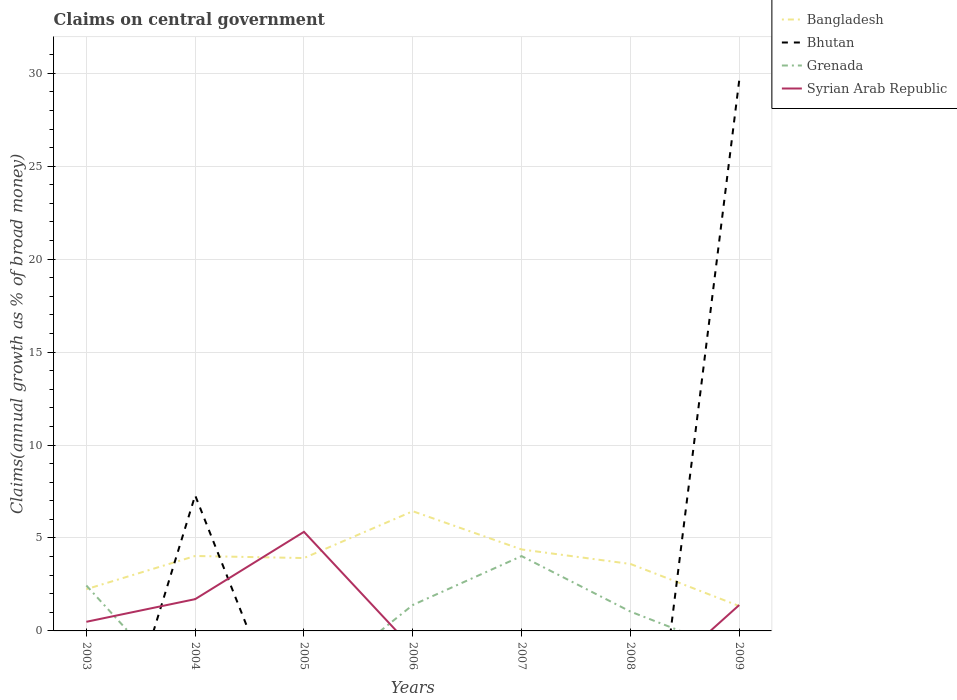Across all years, what is the maximum percentage of broad money claimed on centeral government in Grenada?
Your answer should be compact. 0. What is the total percentage of broad money claimed on centeral government in Bhutan in the graph?
Your answer should be very brief. -22.33. What is the difference between the highest and the second highest percentage of broad money claimed on centeral government in Syrian Arab Republic?
Your answer should be very brief. 5.33. What is the difference between the highest and the lowest percentage of broad money claimed on centeral government in Bhutan?
Provide a short and direct response. 2. How many lines are there?
Ensure brevity in your answer.  4. How many legend labels are there?
Your response must be concise. 4. What is the title of the graph?
Your response must be concise. Claims on central government. What is the label or title of the Y-axis?
Your answer should be compact. Claims(annual growth as % of broad money). What is the Claims(annual growth as % of broad money) in Bangladesh in 2003?
Keep it short and to the point. 2.24. What is the Claims(annual growth as % of broad money) of Grenada in 2003?
Give a very brief answer. 2.44. What is the Claims(annual growth as % of broad money) of Syrian Arab Republic in 2003?
Make the answer very short. 0.49. What is the Claims(annual growth as % of broad money) of Bangladesh in 2004?
Provide a succinct answer. 4.03. What is the Claims(annual growth as % of broad money) of Bhutan in 2004?
Ensure brevity in your answer.  7.29. What is the Claims(annual growth as % of broad money) of Syrian Arab Republic in 2004?
Offer a terse response. 1.71. What is the Claims(annual growth as % of broad money) of Bangladesh in 2005?
Offer a terse response. 3.92. What is the Claims(annual growth as % of broad money) of Syrian Arab Republic in 2005?
Provide a succinct answer. 5.33. What is the Claims(annual growth as % of broad money) of Bangladesh in 2006?
Your answer should be compact. 6.44. What is the Claims(annual growth as % of broad money) of Grenada in 2006?
Your response must be concise. 1.4. What is the Claims(annual growth as % of broad money) of Bangladesh in 2007?
Offer a terse response. 4.38. What is the Claims(annual growth as % of broad money) of Bhutan in 2007?
Your answer should be very brief. 0. What is the Claims(annual growth as % of broad money) of Grenada in 2007?
Offer a terse response. 4.03. What is the Claims(annual growth as % of broad money) in Bangladesh in 2008?
Keep it short and to the point. 3.6. What is the Claims(annual growth as % of broad money) in Grenada in 2008?
Keep it short and to the point. 1.04. What is the Claims(annual growth as % of broad money) in Syrian Arab Republic in 2008?
Provide a short and direct response. 0. What is the Claims(annual growth as % of broad money) in Bangladesh in 2009?
Your response must be concise. 1.34. What is the Claims(annual growth as % of broad money) in Bhutan in 2009?
Offer a very short reply. 29.62. What is the Claims(annual growth as % of broad money) of Syrian Arab Republic in 2009?
Provide a succinct answer. 1.39. Across all years, what is the maximum Claims(annual growth as % of broad money) of Bangladesh?
Offer a very short reply. 6.44. Across all years, what is the maximum Claims(annual growth as % of broad money) of Bhutan?
Offer a terse response. 29.62. Across all years, what is the maximum Claims(annual growth as % of broad money) in Grenada?
Make the answer very short. 4.03. Across all years, what is the maximum Claims(annual growth as % of broad money) in Syrian Arab Republic?
Your response must be concise. 5.33. Across all years, what is the minimum Claims(annual growth as % of broad money) of Bangladesh?
Offer a terse response. 1.34. Across all years, what is the minimum Claims(annual growth as % of broad money) in Grenada?
Ensure brevity in your answer.  0. Across all years, what is the minimum Claims(annual growth as % of broad money) in Syrian Arab Republic?
Give a very brief answer. 0. What is the total Claims(annual growth as % of broad money) in Bangladesh in the graph?
Provide a succinct answer. 25.96. What is the total Claims(annual growth as % of broad money) in Bhutan in the graph?
Provide a succinct answer. 36.91. What is the total Claims(annual growth as % of broad money) in Grenada in the graph?
Ensure brevity in your answer.  8.91. What is the total Claims(annual growth as % of broad money) in Syrian Arab Republic in the graph?
Keep it short and to the point. 8.92. What is the difference between the Claims(annual growth as % of broad money) in Bangladesh in 2003 and that in 2004?
Provide a short and direct response. -1.79. What is the difference between the Claims(annual growth as % of broad money) of Syrian Arab Republic in 2003 and that in 2004?
Your response must be concise. -1.22. What is the difference between the Claims(annual growth as % of broad money) of Bangladesh in 2003 and that in 2005?
Keep it short and to the point. -1.68. What is the difference between the Claims(annual growth as % of broad money) in Syrian Arab Republic in 2003 and that in 2005?
Give a very brief answer. -4.84. What is the difference between the Claims(annual growth as % of broad money) in Bangladesh in 2003 and that in 2006?
Offer a terse response. -4.19. What is the difference between the Claims(annual growth as % of broad money) of Grenada in 2003 and that in 2006?
Give a very brief answer. 1.05. What is the difference between the Claims(annual growth as % of broad money) in Bangladesh in 2003 and that in 2007?
Provide a succinct answer. -2.14. What is the difference between the Claims(annual growth as % of broad money) in Grenada in 2003 and that in 2007?
Ensure brevity in your answer.  -1.58. What is the difference between the Claims(annual growth as % of broad money) of Bangladesh in 2003 and that in 2008?
Offer a very short reply. -1.36. What is the difference between the Claims(annual growth as % of broad money) in Grenada in 2003 and that in 2008?
Your answer should be compact. 1.4. What is the difference between the Claims(annual growth as % of broad money) of Bangladesh in 2003 and that in 2009?
Offer a very short reply. 0.91. What is the difference between the Claims(annual growth as % of broad money) in Syrian Arab Republic in 2003 and that in 2009?
Your response must be concise. -0.9. What is the difference between the Claims(annual growth as % of broad money) of Bangladesh in 2004 and that in 2005?
Offer a very short reply. 0.11. What is the difference between the Claims(annual growth as % of broad money) of Syrian Arab Republic in 2004 and that in 2005?
Offer a terse response. -3.62. What is the difference between the Claims(annual growth as % of broad money) of Bangladesh in 2004 and that in 2006?
Your response must be concise. -2.41. What is the difference between the Claims(annual growth as % of broad money) of Bangladesh in 2004 and that in 2007?
Provide a succinct answer. -0.35. What is the difference between the Claims(annual growth as % of broad money) of Bangladesh in 2004 and that in 2008?
Offer a terse response. 0.43. What is the difference between the Claims(annual growth as % of broad money) of Bangladesh in 2004 and that in 2009?
Provide a short and direct response. 2.69. What is the difference between the Claims(annual growth as % of broad money) in Bhutan in 2004 and that in 2009?
Give a very brief answer. -22.33. What is the difference between the Claims(annual growth as % of broad money) of Syrian Arab Republic in 2004 and that in 2009?
Your answer should be compact. 0.32. What is the difference between the Claims(annual growth as % of broad money) in Bangladesh in 2005 and that in 2006?
Offer a terse response. -2.52. What is the difference between the Claims(annual growth as % of broad money) in Bangladesh in 2005 and that in 2007?
Your response must be concise. -0.46. What is the difference between the Claims(annual growth as % of broad money) in Bangladesh in 2005 and that in 2008?
Your answer should be compact. 0.32. What is the difference between the Claims(annual growth as % of broad money) of Bangladesh in 2005 and that in 2009?
Make the answer very short. 2.58. What is the difference between the Claims(annual growth as % of broad money) of Syrian Arab Republic in 2005 and that in 2009?
Your response must be concise. 3.94. What is the difference between the Claims(annual growth as % of broad money) of Bangladesh in 2006 and that in 2007?
Your answer should be compact. 2.06. What is the difference between the Claims(annual growth as % of broad money) in Grenada in 2006 and that in 2007?
Give a very brief answer. -2.63. What is the difference between the Claims(annual growth as % of broad money) in Bangladesh in 2006 and that in 2008?
Keep it short and to the point. 2.84. What is the difference between the Claims(annual growth as % of broad money) of Grenada in 2006 and that in 2008?
Offer a very short reply. 0.35. What is the difference between the Claims(annual growth as % of broad money) of Bangladesh in 2006 and that in 2009?
Give a very brief answer. 5.1. What is the difference between the Claims(annual growth as % of broad money) of Bangladesh in 2007 and that in 2008?
Your answer should be compact. 0.78. What is the difference between the Claims(annual growth as % of broad money) of Grenada in 2007 and that in 2008?
Make the answer very short. 2.98. What is the difference between the Claims(annual growth as % of broad money) of Bangladesh in 2007 and that in 2009?
Make the answer very short. 3.04. What is the difference between the Claims(annual growth as % of broad money) of Bangladesh in 2008 and that in 2009?
Give a very brief answer. 2.26. What is the difference between the Claims(annual growth as % of broad money) of Bangladesh in 2003 and the Claims(annual growth as % of broad money) of Bhutan in 2004?
Your response must be concise. -5.05. What is the difference between the Claims(annual growth as % of broad money) in Bangladesh in 2003 and the Claims(annual growth as % of broad money) in Syrian Arab Republic in 2004?
Give a very brief answer. 0.53. What is the difference between the Claims(annual growth as % of broad money) in Grenada in 2003 and the Claims(annual growth as % of broad money) in Syrian Arab Republic in 2004?
Give a very brief answer. 0.73. What is the difference between the Claims(annual growth as % of broad money) of Bangladesh in 2003 and the Claims(annual growth as % of broad money) of Syrian Arab Republic in 2005?
Your answer should be compact. -3.09. What is the difference between the Claims(annual growth as % of broad money) in Grenada in 2003 and the Claims(annual growth as % of broad money) in Syrian Arab Republic in 2005?
Ensure brevity in your answer.  -2.89. What is the difference between the Claims(annual growth as % of broad money) of Bangladesh in 2003 and the Claims(annual growth as % of broad money) of Grenada in 2006?
Make the answer very short. 0.85. What is the difference between the Claims(annual growth as % of broad money) of Bangladesh in 2003 and the Claims(annual growth as % of broad money) of Grenada in 2007?
Make the answer very short. -1.78. What is the difference between the Claims(annual growth as % of broad money) in Bangladesh in 2003 and the Claims(annual growth as % of broad money) in Grenada in 2008?
Offer a very short reply. 1.2. What is the difference between the Claims(annual growth as % of broad money) in Bangladesh in 2003 and the Claims(annual growth as % of broad money) in Bhutan in 2009?
Offer a very short reply. -27.38. What is the difference between the Claims(annual growth as % of broad money) of Bangladesh in 2003 and the Claims(annual growth as % of broad money) of Syrian Arab Republic in 2009?
Provide a short and direct response. 0.85. What is the difference between the Claims(annual growth as % of broad money) of Grenada in 2003 and the Claims(annual growth as % of broad money) of Syrian Arab Republic in 2009?
Your answer should be very brief. 1.05. What is the difference between the Claims(annual growth as % of broad money) of Bangladesh in 2004 and the Claims(annual growth as % of broad money) of Syrian Arab Republic in 2005?
Give a very brief answer. -1.3. What is the difference between the Claims(annual growth as % of broad money) in Bhutan in 2004 and the Claims(annual growth as % of broad money) in Syrian Arab Republic in 2005?
Provide a short and direct response. 1.96. What is the difference between the Claims(annual growth as % of broad money) of Bangladesh in 2004 and the Claims(annual growth as % of broad money) of Grenada in 2006?
Your answer should be compact. 2.64. What is the difference between the Claims(annual growth as % of broad money) in Bhutan in 2004 and the Claims(annual growth as % of broad money) in Grenada in 2006?
Your response must be concise. 5.9. What is the difference between the Claims(annual growth as % of broad money) of Bangladesh in 2004 and the Claims(annual growth as % of broad money) of Grenada in 2007?
Offer a terse response. 0.01. What is the difference between the Claims(annual growth as % of broad money) in Bhutan in 2004 and the Claims(annual growth as % of broad money) in Grenada in 2007?
Offer a terse response. 3.27. What is the difference between the Claims(annual growth as % of broad money) of Bangladesh in 2004 and the Claims(annual growth as % of broad money) of Grenada in 2008?
Give a very brief answer. 2.99. What is the difference between the Claims(annual growth as % of broad money) in Bhutan in 2004 and the Claims(annual growth as % of broad money) in Grenada in 2008?
Your answer should be compact. 6.25. What is the difference between the Claims(annual growth as % of broad money) in Bangladesh in 2004 and the Claims(annual growth as % of broad money) in Bhutan in 2009?
Provide a short and direct response. -25.59. What is the difference between the Claims(annual growth as % of broad money) in Bangladesh in 2004 and the Claims(annual growth as % of broad money) in Syrian Arab Republic in 2009?
Make the answer very short. 2.64. What is the difference between the Claims(annual growth as % of broad money) of Bhutan in 2004 and the Claims(annual growth as % of broad money) of Syrian Arab Republic in 2009?
Ensure brevity in your answer.  5.9. What is the difference between the Claims(annual growth as % of broad money) of Bangladesh in 2005 and the Claims(annual growth as % of broad money) of Grenada in 2006?
Your answer should be compact. 2.52. What is the difference between the Claims(annual growth as % of broad money) of Bangladesh in 2005 and the Claims(annual growth as % of broad money) of Grenada in 2007?
Give a very brief answer. -0.11. What is the difference between the Claims(annual growth as % of broad money) in Bangladesh in 2005 and the Claims(annual growth as % of broad money) in Grenada in 2008?
Make the answer very short. 2.88. What is the difference between the Claims(annual growth as % of broad money) of Bangladesh in 2005 and the Claims(annual growth as % of broad money) of Bhutan in 2009?
Make the answer very short. -25.7. What is the difference between the Claims(annual growth as % of broad money) in Bangladesh in 2005 and the Claims(annual growth as % of broad money) in Syrian Arab Republic in 2009?
Offer a terse response. 2.53. What is the difference between the Claims(annual growth as % of broad money) of Bangladesh in 2006 and the Claims(annual growth as % of broad money) of Grenada in 2007?
Your answer should be compact. 2.41. What is the difference between the Claims(annual growth as % of broad money) in Bangladesh in 2006 and the Claims(annual growth as % of broad money) in Grenada in 2008?
Keep it short and to the point. 5.4. What is the difference between the Claims(annual growth as % of broad money) in Bangladesh in 2006 and the Claims(annual growth as % of broad money) in Bhutan in 2009?
Your response must be concise. -23.18. What is the difference between the Claims(annual growth as % of broad money) in Bangladesh in 2006 and the Claims(annual growth as % of broad money) in Syrian Arab Republic in 2009?
Give a very brief answer. 5.05. What is the difference between the Claims(annual growth as % of broad money) in Grenada in 2006 and the Claims(annual growth as % of broad money) in Syrian Arab Republic in 2009?
Offer a very short reply. 0. What is the difference between the Claims(annual growth as % of broad money) of Bangladesh in 2007 and the Claims(annual growth as % of broad money) of Grenada in 2008?
Your answer should be very brief. 3.34. What is the difference between the Claims(annual growth as % of broad money) of Bangladesh in 2007 and the Claims(annual growth as % of broad money) of Bhutan in 2009?
Your response must be concise. -25.24. What is the difference between the Claims(annual growth as % of broad money) in Bangladesh in 2007 and the Claims(annual growth as % of broad money) in Syrian Arab Republic in 2009?
Give a very brief answer. 2.99. What is the difference between the Claims(annual growth as % of broad money) in Grenada in 2007 and the Claims(annual growth as % of broad money) in Syrian Arab Republic in 2009?
Offer a terse response. 2.63. What is the difference between the Claims(annual growth as % of broad money) of Bangladesh in 2008 and the Claims(annual growth as % of broad money) of Bhutan in 2009?
Give a very brief answer. -26.02. What is the difference between the Claims(annual growth as % of broad money) in Bangladesh in 2008 and the Claims(annual growth as % of broad money) in Syrian Arab Republic in 2009?
Your answer should be compact. 2.21. What is the difference between the Claims(annual growth as % of broad money) of Grenada in 2008 and the Claims(annual growth as % of broad money) of Syrian Arab Republic in 2009?
Your answer should be very brief. -0.35. What is the average Claims(annual growth as % of broad money) of Bangladesh per year?
Your answer should be very brief. 3.71. What is the average Claims(annual growth as % of broad money) of Bhutan per year?
Provide a short and direct response. 5.27. What is the average Claims(annual growth as % of broad money) of Grenada per year?
Offer a terse response. 1.27. What is the average Claims(annual growth as % of broad money) in Syrian Arab Republic per year?
Ensure brevity in your answer.  1.27. In the year 2003, what is the difference between the Claims(annual growth as % of broad money) of Bangladesh and Claims(annual growth as % of broad money) of Grenada?
Provide a short and direct response. -0.2. In the year 2003, what is the difference between the Claims(annual growth as % of broad money) in Bangladesh and Claims(annual growth as % of broad money) in Syrian Arab Republic?
Your response must be concise. 1.75. In the year 2003, what is the difference between the Claims(annual growth as % of broad money) of Grenada and Claims(annual growth as % of broad money) of Syrian Arab Republic?
Offer a terse response. 1.95. In the year 2004, what is the difference between the Claims(annual growth as % of broad money) of Bangladesh and Claims(annual growth as % of broad money) of Bhutan?
Offer a terse response. -3.26. In the year 2004, what is the difference between the Claims(annual growth as % of broad money) in Bangladesh and Claims(annual growth as % of broad money) in Syrian Arab Republic?
Provide a short and direct response. 2.32. In the year 2004, what is the difference between the Claims(annual growth as % of broad money) of Bhutan and Claims(annual growth as % of broad money) of Syrian Arab Republic?
Make the answer very short. 5.58. In the year 2005, what is the difference between the Claims(annual growth as % of broad money) of Bangladesh and Claims(annual growth as % of broad money) of Syrian Arab Republic?
Provide a succinct answer. -1.41. In the year 2006, what is the difference between the Claims(annual growth as % of broad money) in Bangladesh and Claims(annual growth as % of broad money) in Grenada?
Offer a terse response. 5.04. In the year 2007, what is the difference between the Claims(annual growth as % of broad money) of Bangladesh and Claims(annual growth as % of broad money) of Grenada?
Offer a terse response. 0.36. In the year 2008, what is the difference between the Claims(annual growth as % of broad money) in Bangladesh and Claims(annual growth as % of broad money) in Grenada?
Make the answer very short. 2.56. In the year 2009, what is the difference between the Claims(annual growth as % of broad money) in Bangladesh and Claims(annual growth as % of broad money) in Bhutan?
Offer a very short reply. -28.28. In the year 2009, what is the difference between the Claims(annual growth as % of broad money) in Bangladesh and Claims(annual growth as % of broad money) in Syrian Arab Republic?
Your response must be concise. -0.06. In the year 2009, what is the difference between the Claims(annual growth as % of broad money) of Bhutan and Claims(annual growth as % of broad money) of Syrian Arab Republic?
Ensure brevity in your answer.  28.23. What is the ratio of the Claims(annual growth as % of broad money) in Bangladesh in 2003 to that in 2004?
Make the answer very short. 0.56. What is the ratio of the Claims(annual growth as % of broad money) of Syrian Arab Republic in 2003 to that in 2004?
Your answer should be compact. 0.29. What is the ratio of the Claims(annual growth as % of broad money) of Bangladesh in 2003 to that in 2005?
Keep it short and to the point. 0.57. What is the ratio of the Claims(annual growth as % of broad money) in Syrian Arab Republic in 2003 to that in 2005?
Your answer should be compact. 0.09. What is the ratio of the Claims(annual growth as % of broad money) in Bangladesh in 2003 to that in 2006?
Provide a succinct answer. 0.35. What is the ratio of the Claims(annual growth as % of broad money) of Grenada in 2003 to that in 2006?
Offer a terse response. 1.75. What is the ratio of the Claims(annual growth as % of broad money) in Bangladesh in 2003 to that in 2007?
Offer a very short reply. 0.51. What is the ratio of the Claims(annual growth as % of broad money) of Grenada in 2003 to that in 2007?
Your answer should be very brief. 0.61. What is the ratio of the Claims(annual growth as % of broad money) of Bangladesh in 2003 to that in 2008?
Provide a short and direct response. 0.62. What is the ratio of the Claims(annual growth as % of broad money) in Grenada in 2003 to that in 2008?
Give a very brief answer. 2.35. What is the ratio of the Claims(annual growth as % of broad money) of Bangladesh in 2003 to that in 2009?
Keep it short and to the point. 1.68. What is the ratio of the Claims(annual growth as % of broad money) in Syrian Arab Republic in 2003 to that in 2009?
Provide a short and direct response. 0.35. What is the ratio of the Claims(annual growth as % of broad money) in Bangladesh in 2004 to that in 2005?
Your answer should be very brief. 1.03. What is the ratio of the Claims(annual growth as % of broad money) in Syrian Arab Republic in 2004 to that in 2005?
Provide a succinct answer. 0.32. What is the ratio of the Claims(annual growth as % of broad money) in Bangladesh in 2004 to that in 2006?
Keep it short and to the point. 0.63. What is the ratio of the Claims(annual growth as % of broad money) in Bangladesh in 2004 to that in 2007?
Your answer should be very brief. 0.92. What is the ratio of the Claims(annual growth as % of broad money) of Bangladesh in 2004 to that in 2008?
Your answer should be compact. 1.12. What is the ratio of the Claims(annual growth as % of broad money) in Bangladesh in 2004 to that in 2009?
Your response must be concise. 3.01. What is the ratio of the Claims(annual growth as % of broad money) in Bhutan in 2004 to that in 2009?
Offer a very short reply. 0.25. What is the ratio of the Claims(annual growth as % of broad money) of Syrian Arab Republic in 2004 to that in 2009?
Your response must be concise. 1.23. What is the ratio of the Claims(annual growth as % of broad money) in Bangladesh in 2005 to that in 2006?
Keep it short and to the point. 0.61. What is the ratio of the Claims(annual growth as % of broad money) of Bangladesh in 2005 to that in 2007?
Offer a very short reply. 0.89. What is the ratio of the Claims(annual growth as % of broad money) of Bangladesh in 2005 to that in 2008?
Your response must be concise. 1.09. What is the ratio of the Claims(annual growth as % of broad money) in Bangladesh in 2005 to that in 2009?
Make the answer very short. 2.93. What is the ratio of the Claims(annual growth as % of broad money) in Syrian Arab Republic in 2005 to that in 2009?
Provide a short and direct response. 3.83. What is the ratio of the Claims(annual growth as % of broad money) in Bangladesh in 2006 to that in 2007?
Your answer should be very brief. 1.47. What is the ratio of the Claims(annual growth as % of broad money) of Grenada in 2006 to that in 2007?
Keep it short and to the point. 0.35. What is the ratio of the Claims(annual growth as % of broad money) in Bangladesh in 2006 to that in 2008?
Offer a very short reply. 1.79. What is the ratio of the Claims(annual growth as % of broad money) in Grenada in 2006 to that in 2008?
Make the answer very short. 1.34. What is the ratio of the Claims(annual growth as % of broad money) in Bangladesh in 2006 to that in 2009?
Your answer should be very brief. 4.81. What is the ratio of the Claims(annual growth as % of broad money) in Bangladesh in 2007 to that in 2008?
Ensure brevity in your answer.  1.22. What is the ratio of the Claims(annual growth as % of broad money) of Grenada in 2007 to that in 2008?
Offer a terse response. 3.87. What is the ratio of the Claims(annual growth as % of broad money) in Bangladesh in 2007 to that in 2009?
Provide a succinct answer. 3.27. What is the ratio of the Claims(annual growth as % of broad money) of Bangladesh in 2008 to that in 2009?
Provide a succinct answer. 2.69. What is the difference between the highest and the second highest Claims(annual growth as % of broad money) in Bangladesh?
Offer a terse response. 2.06. What is the difference between the highest and the second highest Claims(annual growth as % of broad money) of Grenada?
Make the answer very short. 1.58. What is the difference between the highest and the second highest Claims(annual growth as % of broad money) in Syrian Arab Republic?
Provide a short and direct response. 3.62. What is the difference between the highest and the lowest Claims(annual growth as % of broad money) in Bangladesh?
Keep it short and to the point. 5.1. What is the difference between the highest and the lowest Claims(annual growth as % of broad money) of Bhutan?
Your answer should be compact. 29.62. What is the difference between the highest and the lowest Claims(annual growth as % of broad money) in Grenada?
Keep it short and to the point. 4.03. What is the difference between the highest and the lowest Claims(annual growth as % of broad money) in Syrian Arab Republic?
Your answer should be very brief. 5.33. 